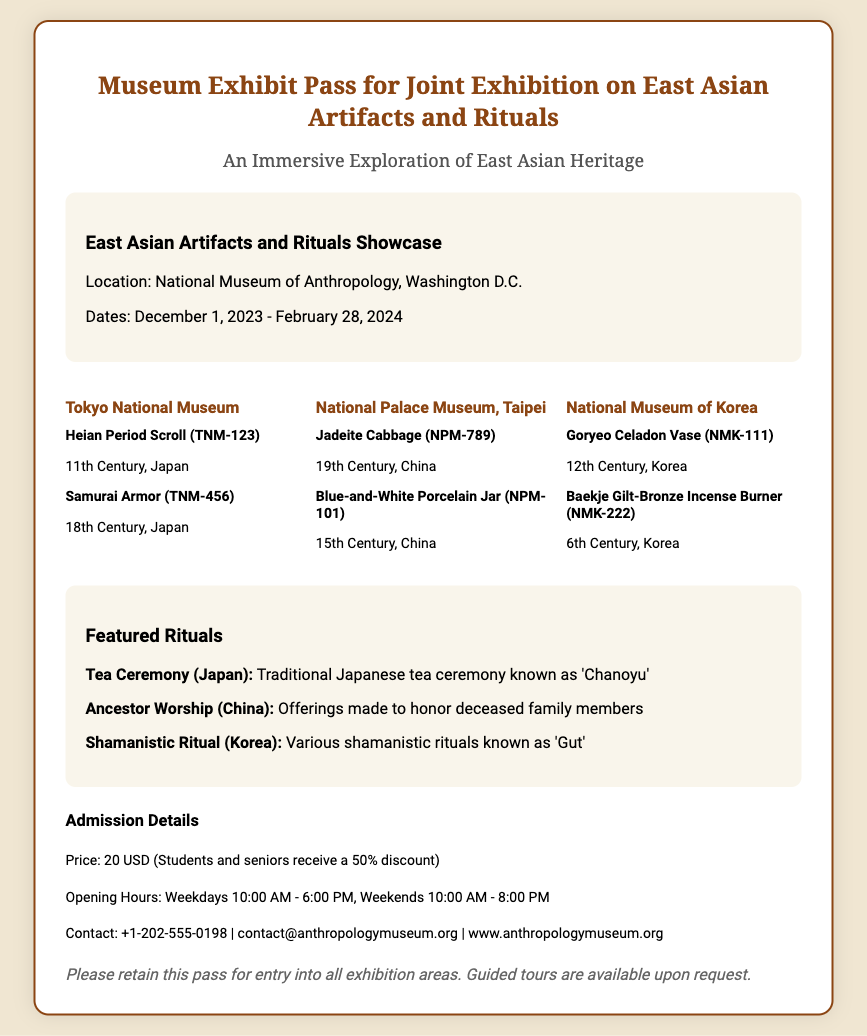What is the location of the exhibition? The location of the exhibition is mentioned in the exhibition details section.
Answer: National Museum of Anthropology, Washington D.C What are the dates of the exhibition? The exhibition's dates are specified in the exhibition details section.
Answer: December 1, 2023 - February 28, 2024 How much is the price for admission? The price for admission is provided in the admission details section.
Answer: 20 USD Which artifact is from the 12th Century, Korea? The document lists various artifacts along with their origins and dates.
Answer: Goryeo Celadon Vase What discount do students and seniors receive? The admission details provide information about discounts for students and seniors.
Answer: 50% discount What is the featured ritual from China? The featured rituals section includes specific rituals along with their cultural origins.
Answer: Ancestor Worship Which exhibitor presents the Samurai Armor? The document specifies the exhibitors and their respective artifacts.
Answer: Tokyo National Museum What is the opening hour on weekends? The opening hours are specified for weekdays and weekends in the admission details section.
Answer: 10:00 AM - 8:00 PM 